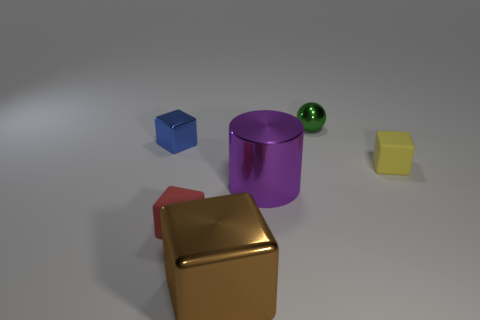Are there any other things that are made of the same material as the small red block?
Your response must be concise. Yes. Is the number of objects that are behind the tiny yellow thing greater than the number of red metal balls?
Ensure brevity in your answer.  Yes. There is a tiny block that is right of the tiny thing in front of the tiny yellow thing; is there a red matte cube behind it?
Your answer should be compact. No. There is a tiny red matte cube; are there any small shiny objects to the right of it?
Give a very brief answer. Yes. How many other big cubes are the same color as the large metal cube?
Provide a succinct answer. 0. What size is the thing that is the same material as the small yellow cube?
Keep it short and to the point. Small. There is a matte thing in front of the small rubber object on the right side of the object behind the tiny blue metallic cube; what is its size?
Your answer should be very brief. Small. What size is the matte block to the right of the brown metallic cube?
Provide a short and direct response. Small. What number of green things are small objects or rubber balls?
Your answer should be compact. 1. Is there a gray block that has the same size as the yellow cube?
Provide a succinct answer. No. 